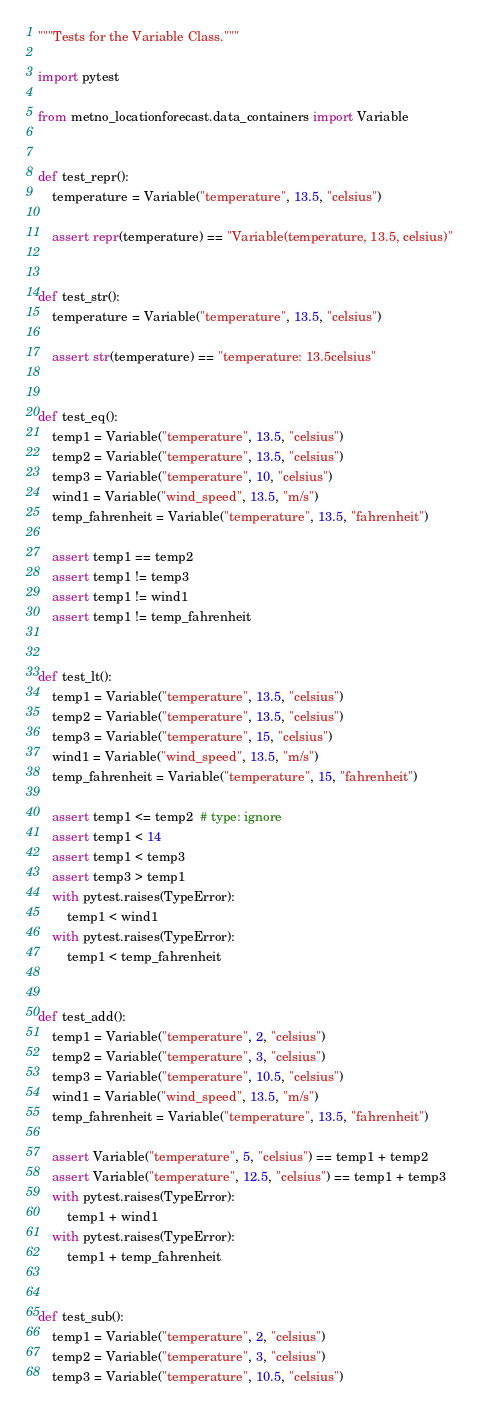Convert code to text. <code><loc_0><loc_0><loc_500><loc_500><_Python_>"""Tests for the Variable Class."""

import pytest

from metno_locationforecast.data_containers import Variable


def test_repr():
    temperature = Variable("temperature", 13.5, "celsius")

    assert repr(temperature) == "Variable(temperature, 13.5, celsius)"


def test_str():
    temperature = Variable("temperature", 13.5, "celsius")

    assert str(temperature) == "temperature: 13.5celsius"


def test_eq():
    temp1 = Variable("temperature", 13.5, "celsius")
    temp2 = Variable("temperature", 13.5, "celsius")
    temp3 = Variable("temperature", 10, "celsius")
    wind1 = Variable("wind_speed", 13.5, "m/s")
    temp_fahrenheit = Variable("temperature", 13.5, "fahrenheit")

    assert temp1 == temp2
    assert temp1 != temp3
    assert temp1 != wind1
    assert temp1 != temp_fahrenheit


def test_lt():
    temp1 = Variable("temperature", 13.5, "celsius")
    temp2 = Variable("temperature", 13.5, "celsius")
    temp3 = Variable("temperature", 15, "celsius")
    wind1 = Variable("wind_speed", 13.5, "m/s")
    temp_fahrenheit = Variable("temperature", 15, "fahrenheit")

    assert temp1 <= temp2  # type: ignore
    assert temp1 < 14
    assert temp1 < temp3
    assert temp3 > temp1
    with pytest.raises(TypeError):
        temp1 < wind1
    with pytest.raises(TypeError):
        temp1 < temp_fahrenheit


def test_add():
    temp1 = Variable("temperature", 2, "celsius")
    temp2 = Variable("temperature", 3, "celsius")
    temp3 = Variable("temperature", 10.5, "celsius")
    wind1 = Variable("wind_speed", 13.5, "m/s")
    temp_fahrenheit = Variable("temperature", 13.5, "fahrenheit")

    assert Variable("temperature", 5, "celsius") == temp1 + temp2
    assert Variable("temperature", 12.5, "celsius") == temp1 + temp3
    with pytest.raises(TypeError):
        temp1 + wind1
    with pytest.raises(TypeError):
        temp1 + temp_fahrenheit


def test_sub():
    temp1 = Variable("temperature", 2, "celsius")
    temp2 = Variable("temperature", 3, "celsius")
    temp3 = Variable("temperature", 10.5, "celsius")</code> 